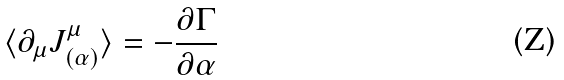<formula> <loc_0><loc_0><loc_500><loc_500>\langle \partial _ { \mu } J ^ { \mu } _ { ( \alpha ) } \rangle = - \frac { \partial \Gamma } { \partial \alpha }</formula> 